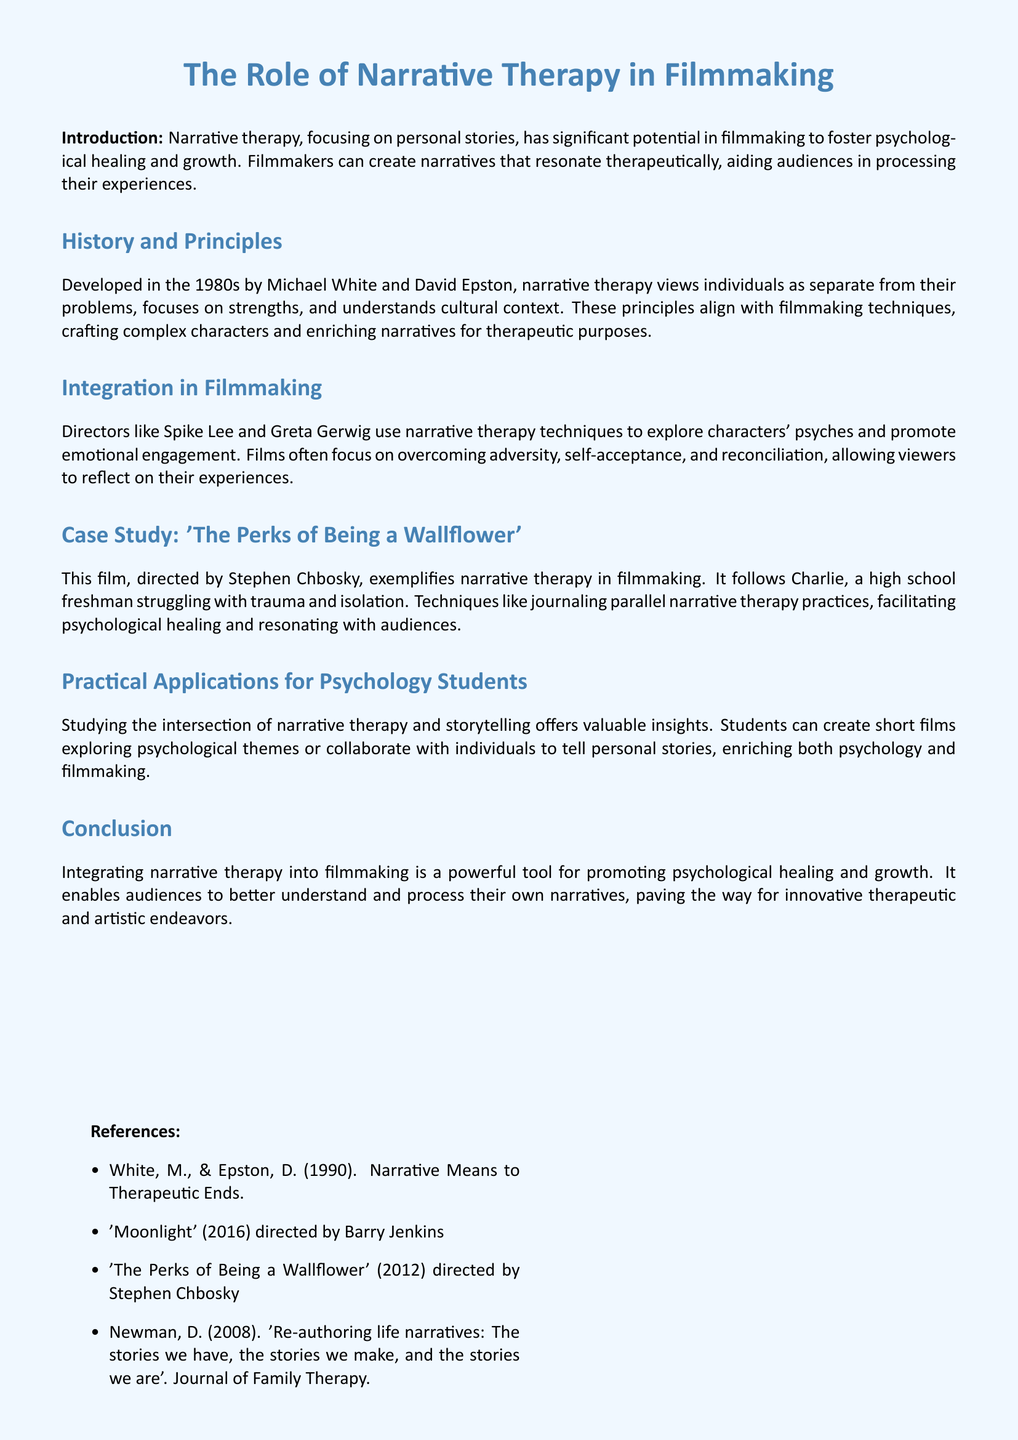What are the main authors of narrative therapy? The main authors of narrative therapy, as mentioned in the document, are Michael White and David Epston.
Answer: Michael White and David Epston What year was narrative therapy developed? The document states that narrative therapy was developed in the 1980s.
Answer: 1980s Which film is used as a case study in the document? The document highlights 'The Perks of Being a Wallflower' as the case study for narrative therapy in filmmaking.
Answer: The Perks of Being a Wallflower What is a key technique mentioned that parallels narrative therapy? The document indicates that journaling is a technique that parallels narrative therapy practices.
Answer: Journaling Which psychological themes can students explore through filmmaking? The document suggests that psychology students can create short films exploring psychological themes.
Answer: Psychological themes Who is the director of 'The Perks of Being a Wallflower'? The director of 'The Perks of Being a Wallflower', as mentioned in the text, is Stephen Chbosky.
Answer: Stephen Chbosky What does narrative therapy focus on according to the document? The document states that narrative therapy focuses on personal stories.
Answer: Personal stories Which director is mentioned for their use of narrative therapy techniques? The document references Spike Lee as a director who uses narrative therapy techniques.
Answer: Spike Lee 